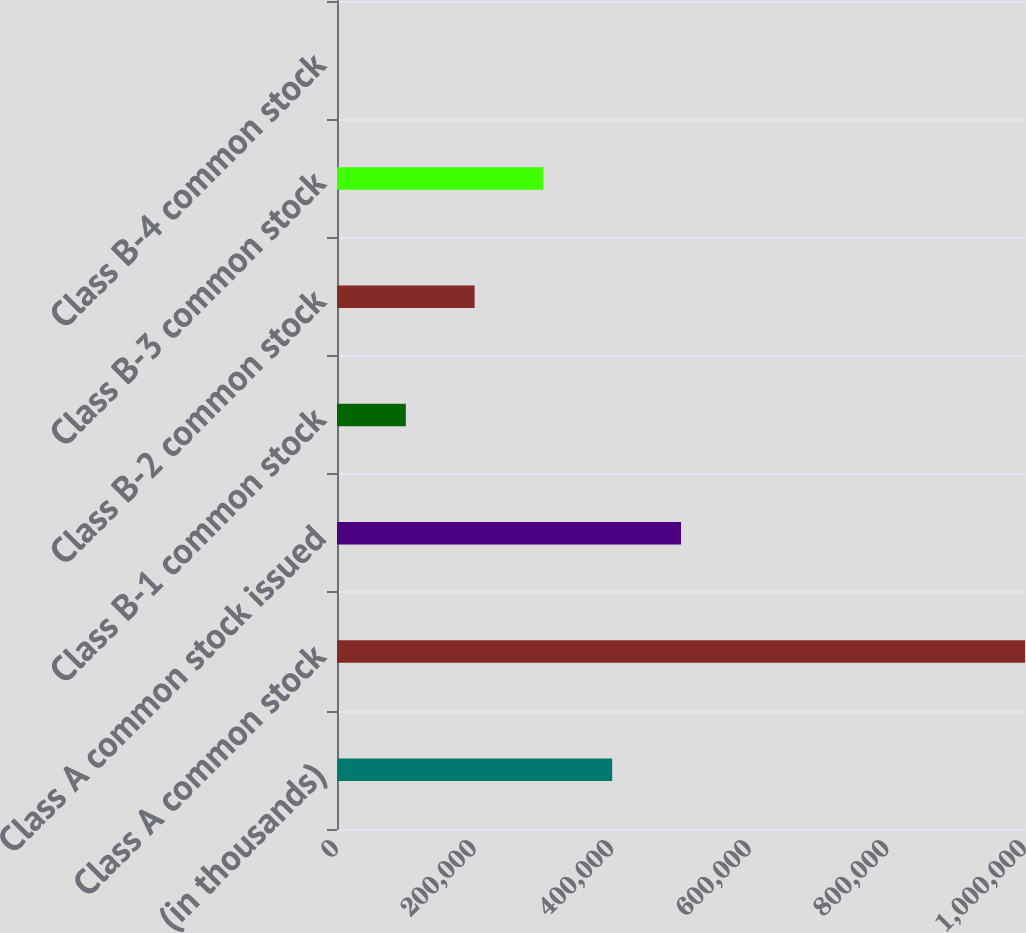Convert chart. <chart><loc_0><loc_0><loc_500><loc_500><bar_chart><fcel>(in thousands)<fcel>Class A common stock<fcel>Class A common stock issued<fcel>Class B-1 common stock<fcel>Class B-2 common stock<fcel>Class B-3 common stock<fcel>Class B-4 common stock<nl><fcel>400000<fcel>1e+06<fcel>500000<fcel>100000<fcel>200000<fcel>300000<fcel>0.4<nl></chart> 